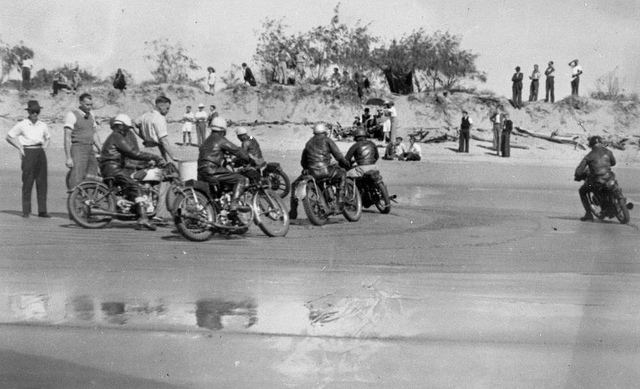Imagine you are one of the racers. Describe your experience. As I rev up my engine, the roar of the other motorcycles around me fills the air, blending with the crashing of the distant waves. My leather jacket is both a shield against the elements and a mark of my readiness for the adrenaline rush that's about to follow. The sand beneath my tires is firm, yet I can feel its subtle shifts as I maneuver my bike into position. The sun beats down, casting sharp shadows, and I exchange a few determined glances with the other racers. The anticipation is electric. When the start signal is given, I feel a surge of power as my motorcycle springs forward, the wind fighting against me as I race towards the horizon. What might have inspired people to participate in such an event? Beach motorcycle races like the one depicted in the image likely gathered enthusiasts for the thrill of speed and competition. Such events offered a sense of community and camaraderie, uniting those who were passionate about motorcycles. For many participants, it was an escape from their daily routines, a way to feel alive and test their skills against others. The beach setting added an element of challenge and beauty, blending the sport with the natural environment. Additionally, during times of economic or social hardship, such events provided an opportunity for entertainment and a sense of normalcy. 